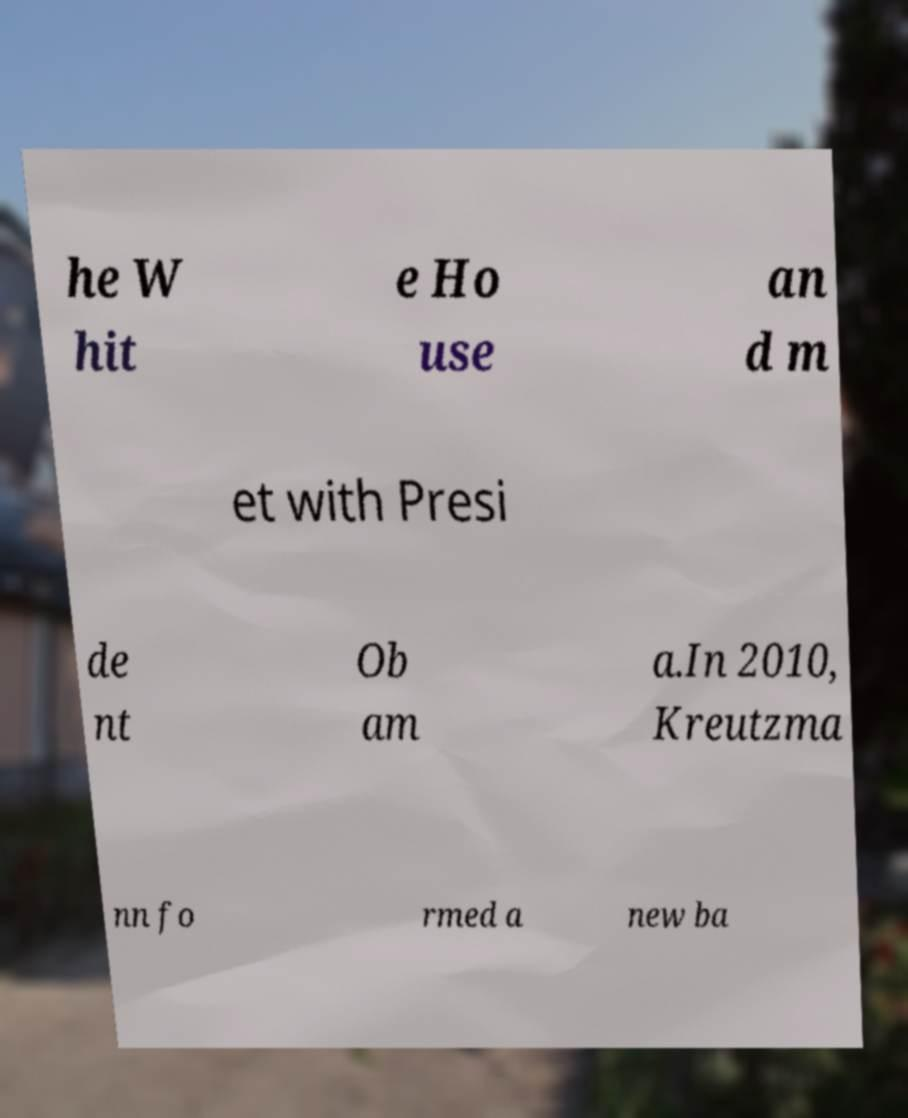Could you extract and type out the text from this image? he W hit e Ho use an d m et with Presi de nt Ob am a.In 2010, Kreutzma nn fo rmed a new ba 